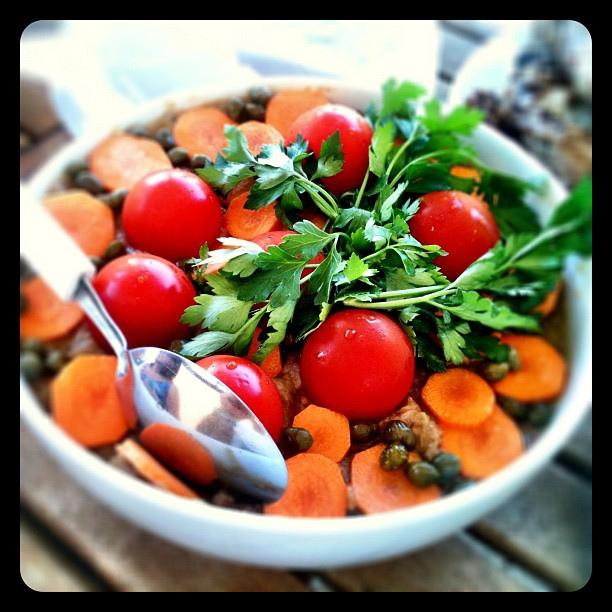How many types of veggies are in the image?
Give a very brief answer. 3. Are there any vegetables in this photo?
Keep it brief. Yes. What are the orange things?
Short answer required. Carrots. Is this cereal?
Concise answer only. No. Do you see raspberries?
Short answer required. No. Where are the stems with leaves?
Keep it brief. On top. What is in the bowl?
Write a very short answer. Vegetables. 